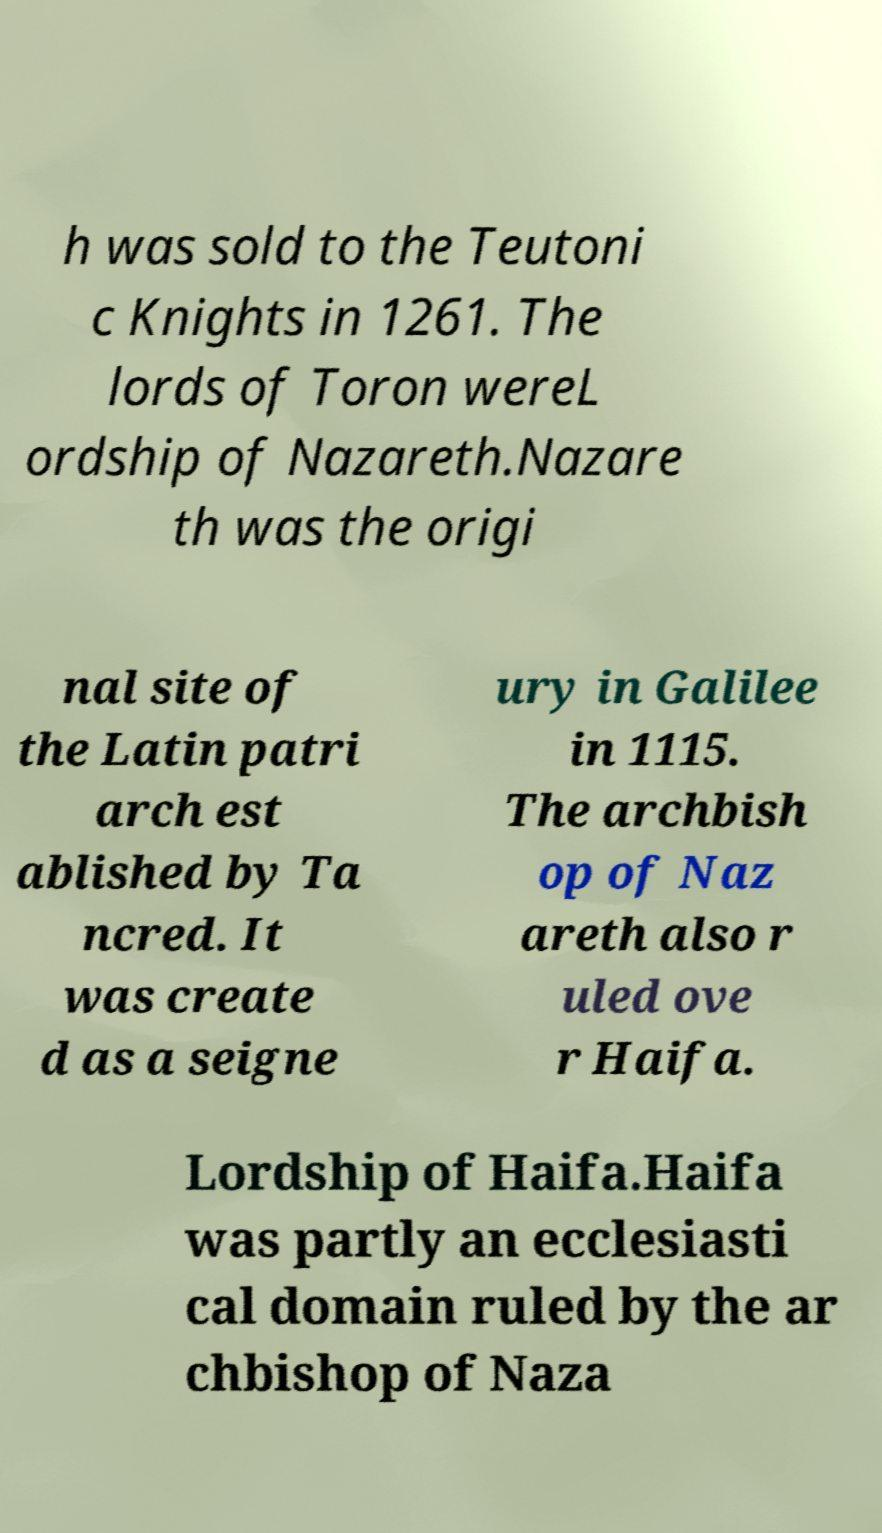Can you read and provide the text displayed in the image?This photo seems to have some interesting text. Can you extract and type it out for me? h was sold to the Teutoni c Knights in 1261. The lords of Toron wereL ordship of Nazareth.Nazare th was the origi nal site of the Latin patri arch est ablished by Ta ncred. It was create d as a seigne ury in Galilee in 1115. The archbish op of Naz areth also r uled ove r Haifa. Lordship of Haifa.Haifa was partly an ecclesiasti cal domain ruled by the ar chbishop of Naza 